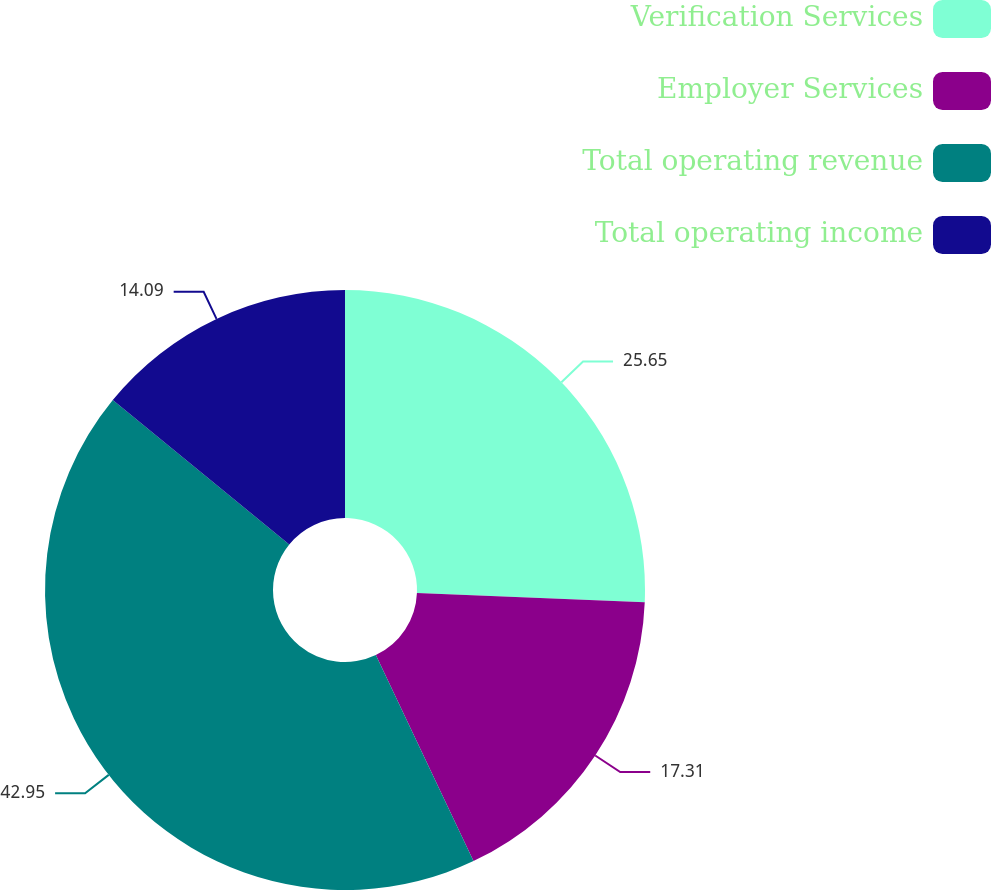Convert chart to OTSL. <chart><loc_0><loc_0><loc_500><loc_500><pie_chart><fcel>Verification Services<fcel>Employer Services<fcel>Total operating revenue<fcel>Total operating income<nl><fcel>25.65%<fcel>17.31%<fcel>42.96%<fcel>14.09%<nl></chart> 